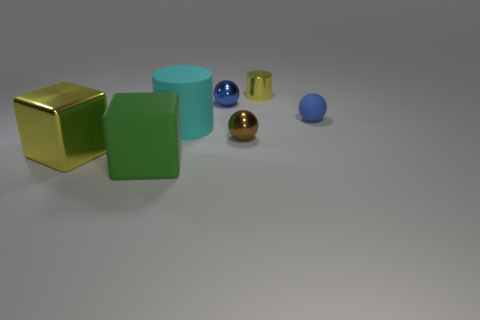Subtract all tiny blue rubber balls. How many balls are left? 2 Subtract all yellow cylinders. How many cylinders are left? 1 Subtract all red cubes. Subtract all red spheres. How many cubes are left? 2 Subtract all cyan blocks. How many brown balls are left? 1 Subtract all large green rubber blocks. Subtract all cyan rubber things. How many objects are left? 5 Add 4 yellow shiny cylinders. How many yellow shiny cylinders are left? 5 Add 3 green objects. How many green objects exist? 4 Add 2 blue cubes. How many objects exist? 9 Subtract 0 brown blocks. How many objects are left? 7 Subtract all balls. How many objects are left? 4 